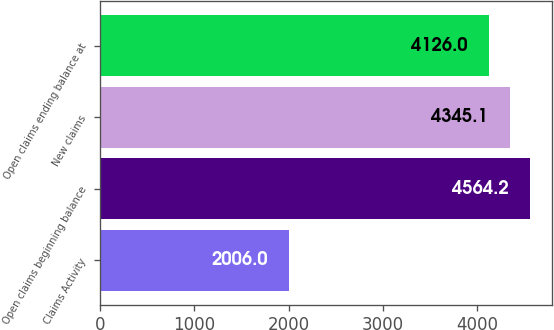Convert chart. <chart><loc_0><loc_0><loc_500><loc_500><bar_chart><fcel>Claims Activity<fcel>Open claims beginning balance<fcel>New claims<fcel>Open claims ending balance at<nl><fcel>2006<fcel>4564.2<fcel>4345.1<fcel>4126<nl></chart> 